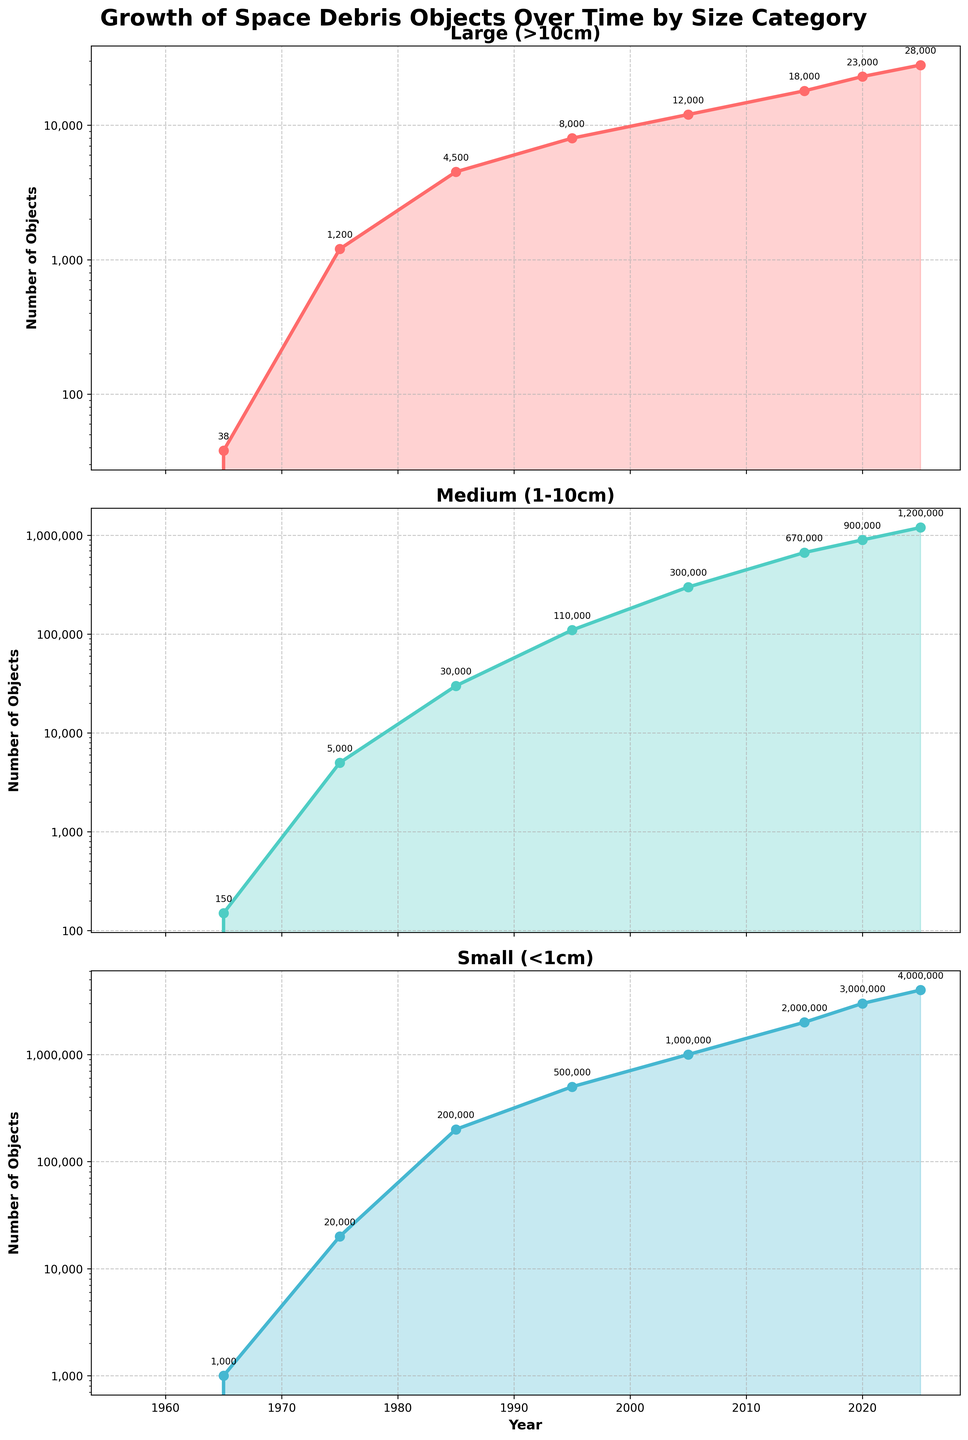What is the title of the subplots figure? The title is located at the top of the figure and serves to describe the content and purpose of the plots. The title reads "Growth of Space Debris Objects Over Time by Size Category".
Answer: Growth of Space Debris Objects Over Time by Size Category Which size category of space debris had the highest number of objects in 2020? Looking at the 2020 data point across the three subplots, the "Small (<1cm)" category has the highest number of objects, reaching 3,000,000.
Answer: Small (<1cm) What is the overall trend for the number of large space debris objects from 1957 to 2025? Observing the line in the "Large (>10cm)" subplot, the number of objects increases steadily over time. This indicates a continuous upward trend from 1957 to 2025.
Answer: Increasing How many medium-sized space debris objects were there in 1985, and how does this compare to 2005? In 1985, the number of medium-sized debris objects is 30,000, while in 2005, it is 300,000. Comparing these two values, it can be observed that the count increased by 270,000 over this period.
Answer: 30,000 in 1985 and 300,000 in 2005 Which year shows the largest increase in the number of small space debris objects compared to the previous data point? By comparing the differences between consecutive data points in the "Small (<1cm)" subplot, the largest increase occurs between 2015 (2,000,000) and 2020 (3,000,000), showing an increase of 1,000,000 objects.
Answer: 2020 What is the approximate growth rate of large space debris objects from 1965 to 1975? The number of large objects in 1965 is 38 and in 1975 is 1,200. The growth rate is calculated by the formula (final value - initial value) / initial value. Therefore, (1200 - 38) / 38 ≈ 30.58.
Answer: Approx. 30.58 What does the y-axis scale represent for the number of debris objects in each size category? Each subplot’s y-axis represents the number of objects in a logarithmic scale, making it easier to visualize changes across several orders of magnitude.
Answer: Logarithmic scale of the number of objects Which categories of space debris experienced exponential growth during the time period observed? Observing the steep upward curves in the "Medium (1-10cm)" and "Small (<1cm)" subplots, both categories demonstrate characteristics of exponential growth.
Answer: Medium (1-10cm) and Small (<1cm) Between which consecutive years did the large debris objects grow by the same absolute amount as the small debris objects? To find this, compare changes in numbers between consecutive years for both categories. From 2020 to 2025, large debris increased by 5,000 (28,000 - 23,000), which matches the increase (4000000 - 3000000) of small debris in the same period.
Answer: 2020 to 2025 